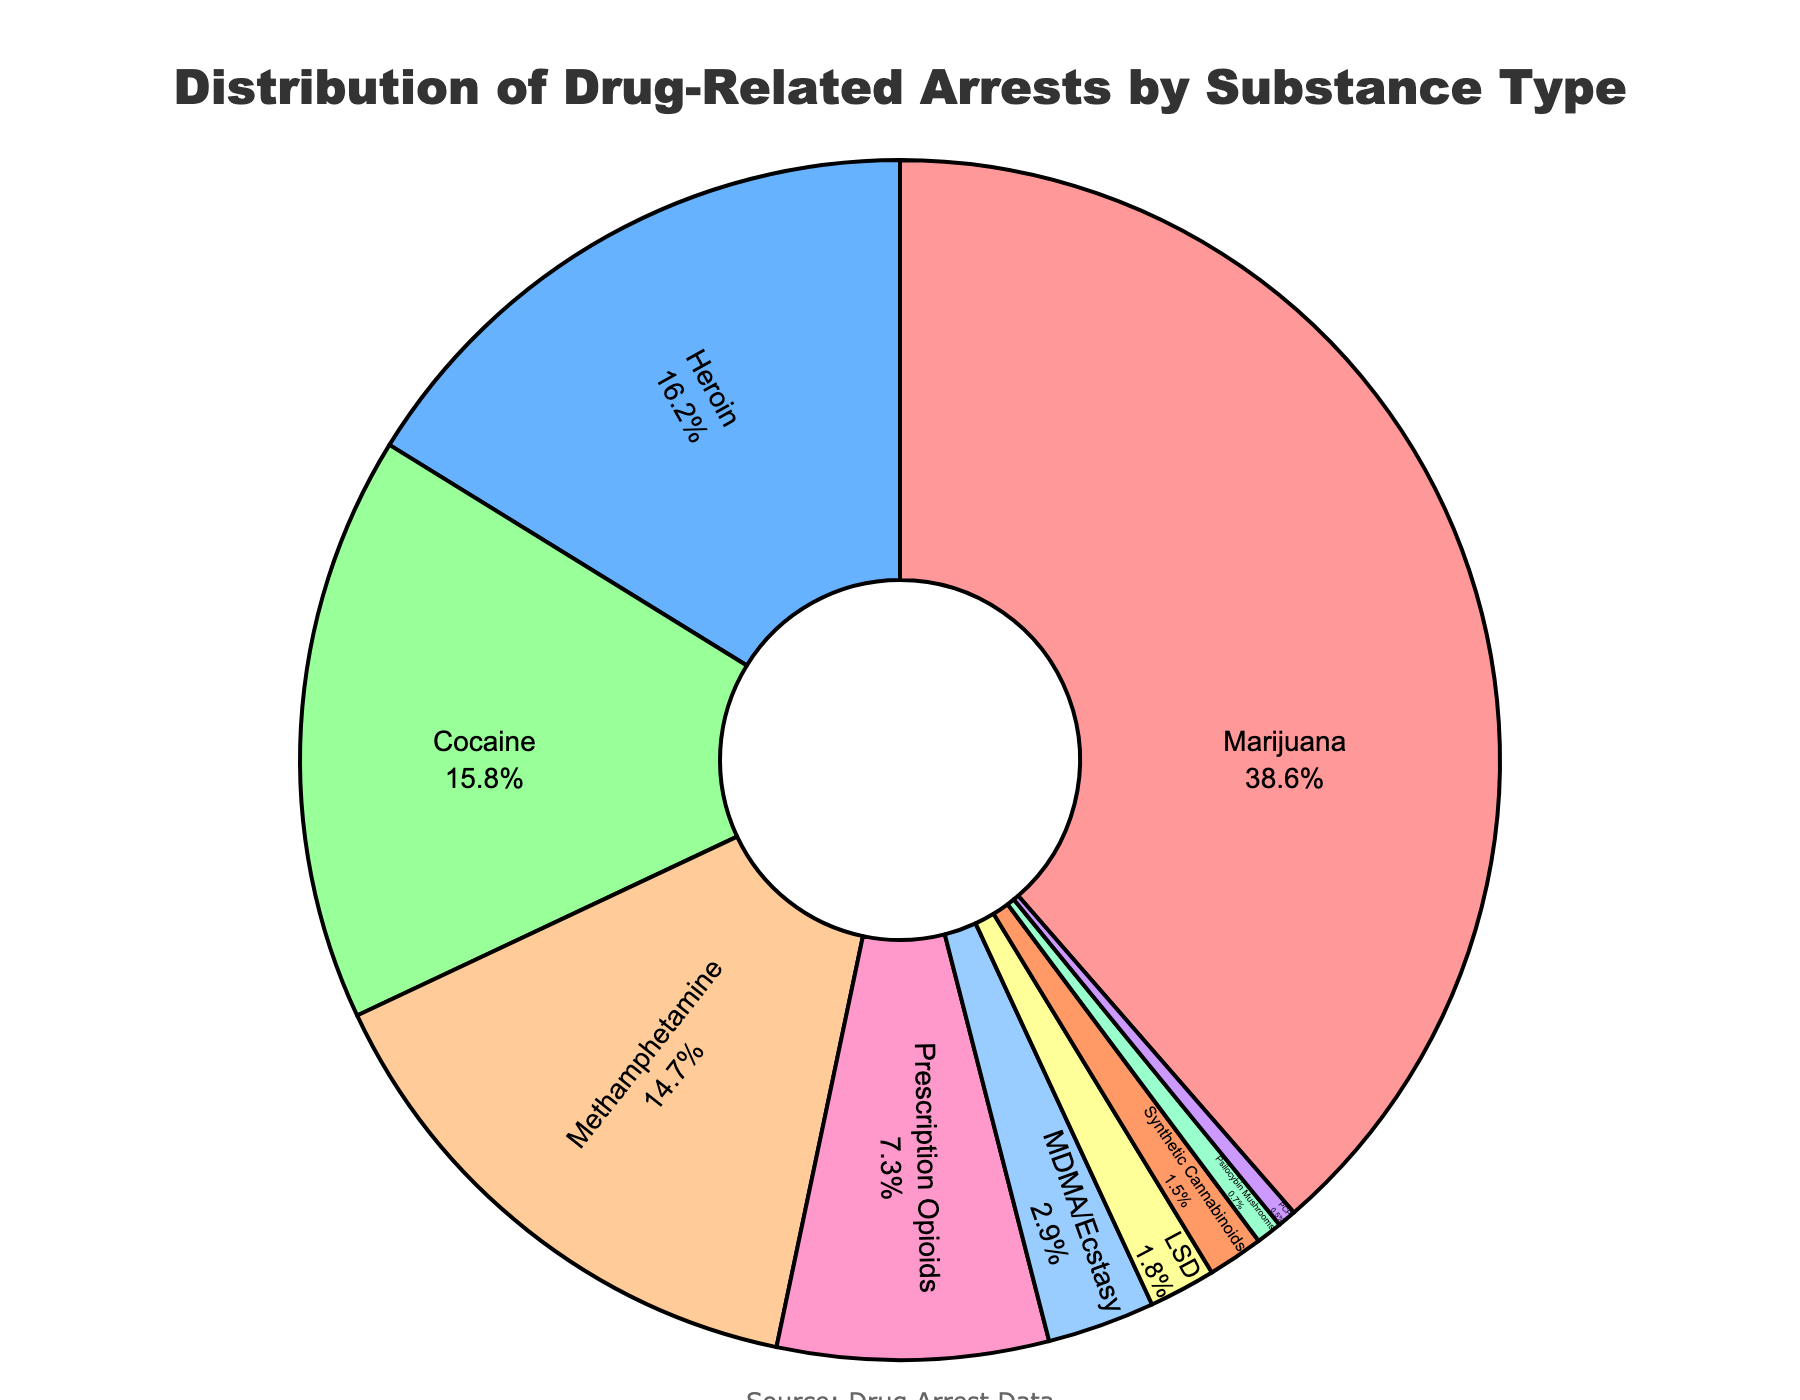Which substance has the largest percentage of drug-related arrests? The largest percentage segment in the pie chart corresponds to the label "Marijuana" with a 38.6% share.
Answer: Marijuana What percentage of drug-related arrests are for Heroin? The pie chart shows a segment labeled "Heroin" with a percentage of 16.2%.
Answer: 16.2% How does the percentage of arrests for Cocaine compare to that for Methamphetamine? The pie chart shows "Cocaine" with a percentage of 15.8%, and "Methamphetamine" with 14.7%. Cocaine has a slightly higher percentage than Methamphetamine.
Answer: Cocaine > Methamphetamine What is the combined percentage of arrests for Marijuana, Heroin, and Cocaine? Add the percentages for Marijuana (38.6%), Heroin (16.2%), and Cocaine (15.8%): 38.6 + 16.2 + 15.8 = 70.6%.
Answer: 70.6% Are there any substances with less than 1% of drug-related arrests, and if so, which ones? The pie chart includes "Psilocybin Mushrooms" with 0.7% and "PCP" with 0.5%, both less than 1%.
Answer: Psilocybin Mushrooms and PCP How does the percentage of arrests for Prescription Opioids compare to that for MDMA/Ecstasy? The pie chart shows "Prescription Opioids" with 7.3% and "MDMA/Ecstasy" with 2.9%. Prescription Opioids have a higher percentage than MDMA/Ecstasy.
Answer: Prescription Opioids > MDMA/Ecstasy Which three substances have the smallest percentages of drug-related arrests? The pie chart shows the smallest segments for "PCP" (0.5%), "Psilocybin Mushrooms" (0.7%), and "Synthetic Cannabinoids" (1.5%).
Answer: PCP, Psilocybin Mushrooms, Synthetic Cannabinoids Compare the combined percentage of arrests for heroin and methamphetamine to that of marijuana. Add the percentages for Heroin (16.2%) and Methamphetamine (14.7%) to get 30.9%. Compare this to Marijuana's 38.6%. The combined percentage for Heroin and Methamphetamine is less than that of Marijuana.
Answer: Heroin + Methamphetamine < Marijuana What is the difference in percentage between the substance with the highest arrests and the substance with the lowest arrests? Marijuana has the highest arrests percentage at 38.6%, and PCP has the lowest at 0.5%. The difference is 38.6 - 0.5 = 38.1%.
Answer: 38.1% What color represents Cocaine in the pie chart? The Cocaine segment in the pie chart is shown in green.
Answer: Green 